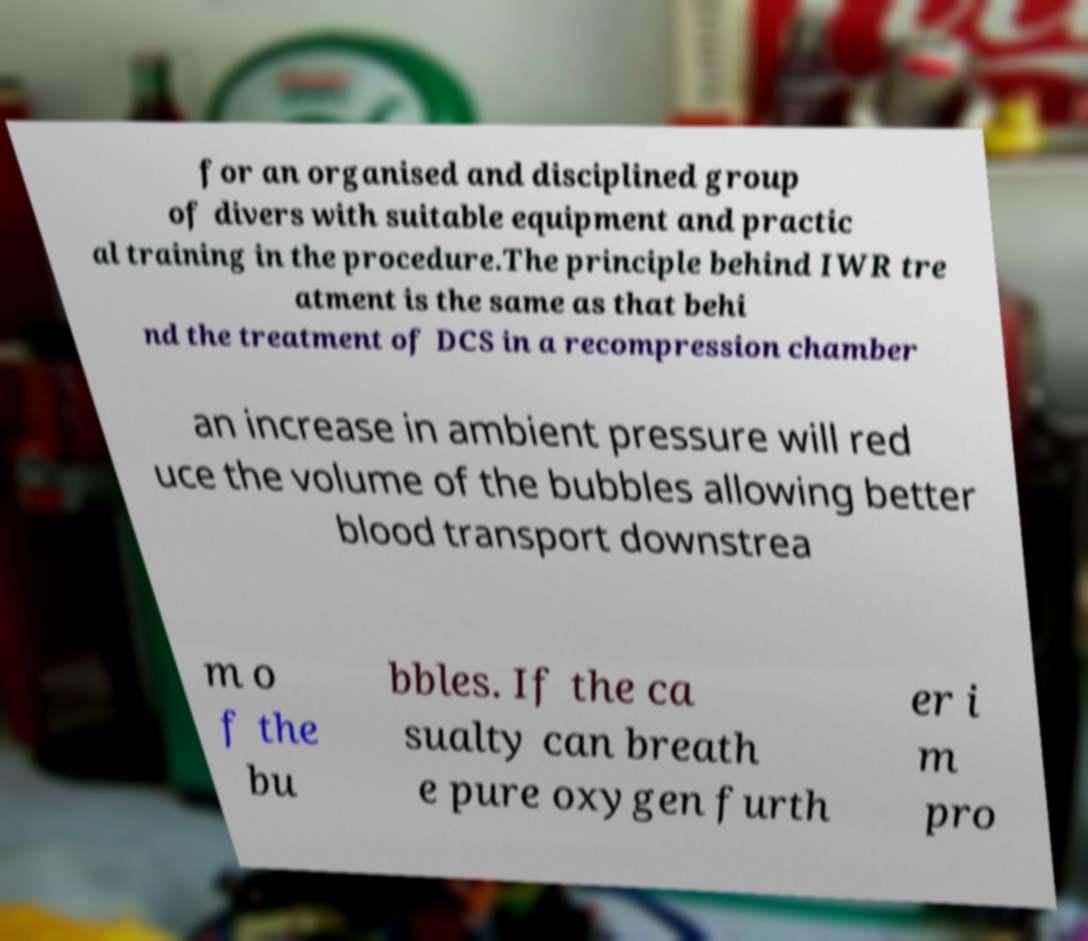Could you extract and type out the text from this image? for an organised and disciplined group of divers with suitable equipment and practic al training in the procedure.The principle behind IWR tre atment is the same as that behi nd the treatment of DCS in a recompression chamber an increase in ambient pressure will red uce the volume of the bubbles allowing better blood transport downstrea m o f the bu bbles. If the ca sualty can breath e pure oxygen furth er i m pro 